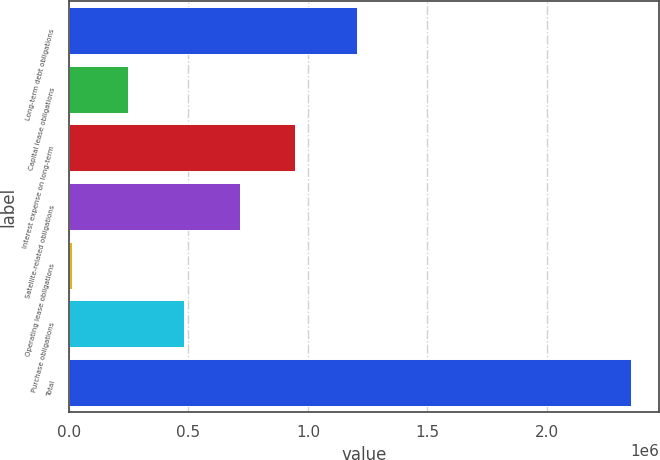Convert chart. <chart><loc_0><loc_0><loc_500><loc_500><bar_chart><fcel>Long-term debt obligations<fcel>Capital lease obligations<fcel>Interest expense on long-term<fcel>Satellite-related obligations<fcel>Operating lease obligations<fcel>Purchase obligations<fcel>Total<nl><fcel>1.20324e+06<fcel>245638<fcel>947551<fcel>713580<fcel>11667<fcel>479609<fcel>2.35138e+06<nl></chart> 